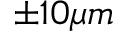<formula> <loc_0><loc_0><loc_500><loc_500>\pm 1 0 \mu m</formula> 